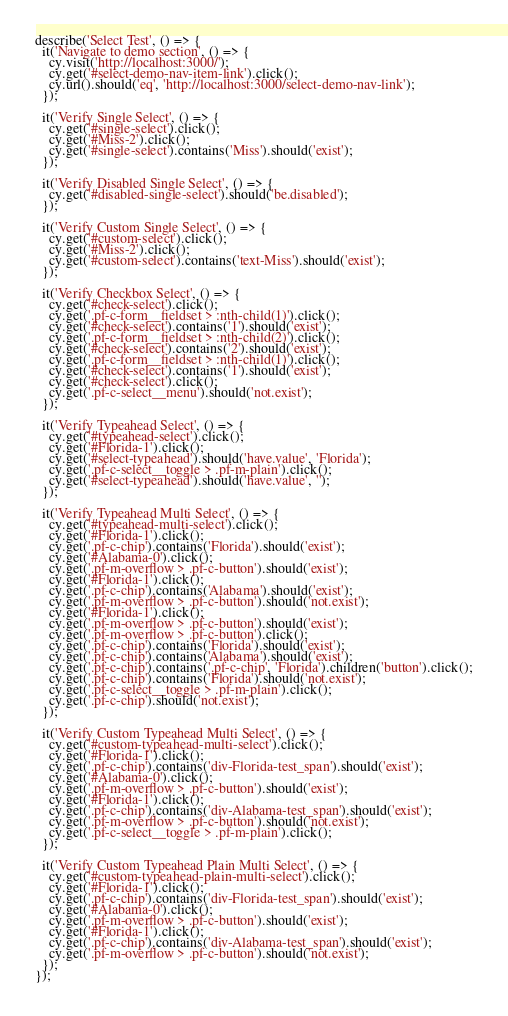<code> <loc_0><loc_0><loc_500><loc_500><_TypeScript_>describe('Select Test', () => {
  it('Navigate to demo section', () => {
    cy.visit('http://localhost:3000/');
    cy.get('#select-demo-nav-item-link').click();
    cy.url().should('eq', 'http://localhost:3000/select-demo-nav-link');
  });

  it('Verify Single Select', () => {
    cy.get('#single-select').click();
    cy.get('#Miss-2').click();
    cy.get('#single-select').contains('Miss').should('exist');
  });

  it('Verify Disabled Single Select', () => {
    cy.get('#disabled-single-select').should('be.disabled');
  });

  it('Verify Custom Single Select', () => {
    cy.get('#custom-select').click();
    cy.get('#Miss-2').click();
    cy.get('#custom-select').contains('text-Miss').should('exist');
  });

  it('Verify Checkbox Select', () => {
    cy.get('#check-select').click();
    cy.get('.pf-c-form__fieldset > :nth-child(1)').click();
    cy.get('#check-select').contains('1').should('exist');
    cy.get('.pf-c-form__fieldset > :nth-child(2)').click();
    cy.get('#check-select').contains('2').should('exist');
    cy.get('.pf-c-form__fieldset > :nth-child(1)').click();
    cy.get('#check-select').contains('1').should('exist');
    cy.get('#check-select').click();
    cy.get('.pf-c-select__menu').should('not.exist');
  });

  it('Verify Typeahead Select', () => {
    cy.get('#typeahead-select').click();
    cy.get('#Florida-1').click();
    cy.get('#select-typeahead').should('have.value', 'Florida');
    cy.get('.pf-c-select__toggle > .pf-m-plain').click();
    cy.get('#select-typeahead').should('have.value', '');
  });

  it('Verify Typeahead Multi Select', () => {
    cy.get('#typeahead-multi-select').click();
    cy.get('#Florida-1').click();
    cy.get('.pf-c-chip').contains('Florida').should('exist');
    cy.get('#Alabama-0').click();
    cy.get('.pf-m-overflow > .pf-c-button').should('exist');
    cy.get('#Florida-1').click();
    cy.get('.pf-c-chip').contains('Alabama').should('exist');
    cy.get('.pf-m-overflow > .pf-c-button').should('not.exist');
    cy.get('#Florida-1').click();
    cy.get('.pf-m-overflow > .pf-c-button').should('exist');
    cy.get('.pf-m-overflow > .pf-c-button').click();
    cy.get('.pf-c-chip').contains('Florida').should('exist');
    cy.get('.pf-c-chip').contains('Alabama').should('exist');
    cy.get('.pf-c-chip').contains('.pf-c-chip', 'Florida').children('button').click();
    cy.get('.pf-c-chip').contains('Florida').should('not.exist');
    cy.get('.pf-c-select__toggle > .pf-m-plain').click();
    cy.get('.pf-c-chip').should('not.exist');
  });

  it('Verify Custom Typeahead Multi Select', () => {
    cy.get('#custom-typeahead-multi-select').click();
    cy.get('#Florida-1').click();
    cy.get('.pf-c-chip').contains('div-Florida-test_span').should('exist');
    cy.get('#Alabama-0').click();
    cy.get('.pf-m-overflow > .pf-c-button').should('exist');
    cy.get('#Florida-1').click();
    cy.get('.pf-c-chip').contains('div-Alabama-test_span').should('exist');
    cy.get('.pf-m-overflow > .pf-c-button').should('not.exist');
    cy.get('.pf-c-select__toggle > .pf-m-plain').click();
  });

  it('Verify Custom Typeahead Plain Multi Select', () => {
    cy.get('#custom-typeahead-plain-multi-select').click();
    cy.get('#Florida-1').click();
    cy.get('.pf-c-chip').contains('div-Florida-test_span').should('exist');
    cy.get('#Alabama-0').click();
    cy.get('.pf-m-overflow > .pf-c-button').should('exist');
    cy.get('#Florida-1').click();
    cy.get('.pf-c-chip').contains('div-Alabama-test_span').should('exist');
    cy.get('.pf-m-overflow > .pf-c-button').should('not.exist');
  });
});
</code> 